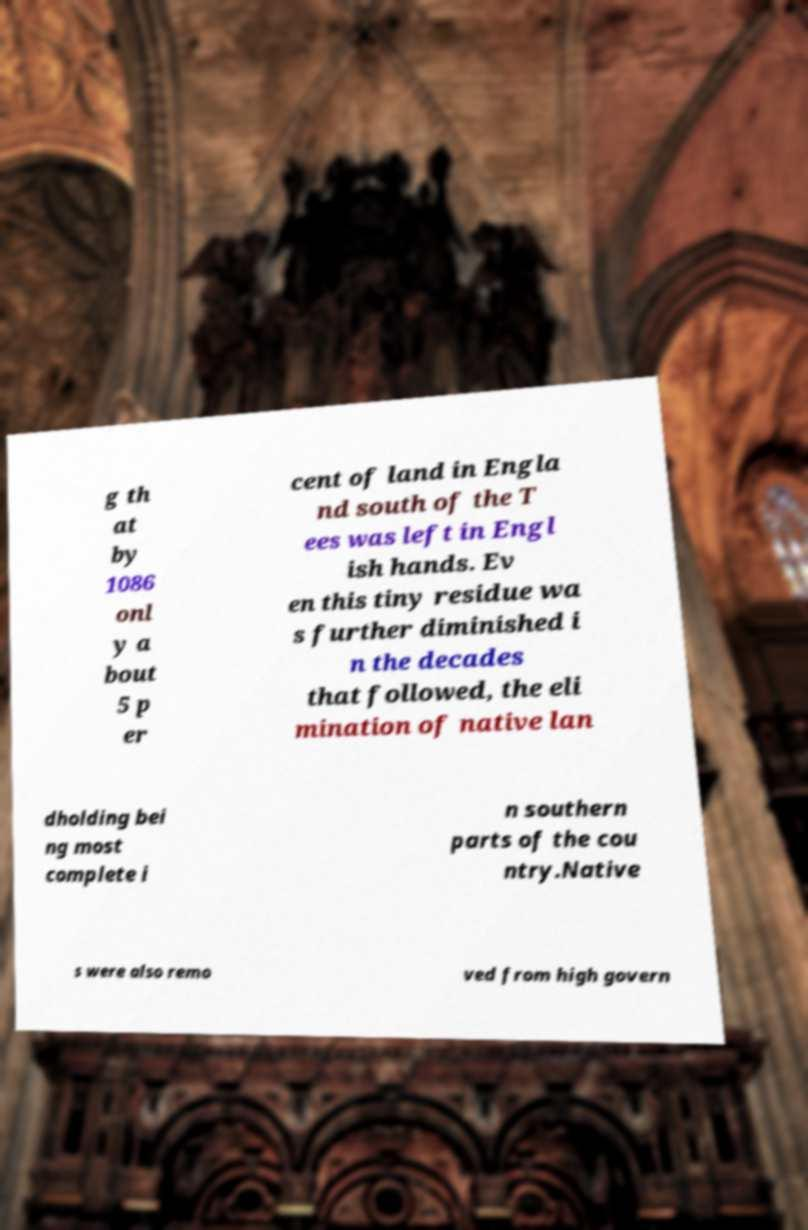Could you assist in decoding the text presented in this image and type it out clearly? g th at by 1086 onl y a bout 5 p er cent of land in Engla nd south of the T ees was left in Engl ish hands. Ev en this tiny residue wa s further diminished i n the decades that followed, the eli mination of native lan dholding bei ng most complete i n southern parts of the cou ntry.Native s were also remo ved from high govern 